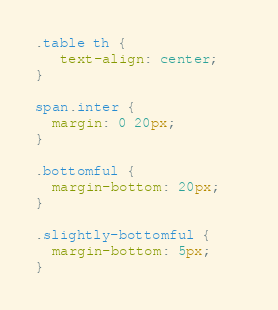Convert code to text. <code><loc_0><loc_0><loc_500><loc_500><_CSS_>.table th {
   text-align: center;   
}

span.inter {
  margin: 0 20px;
}

.bottomful {
  margin-bottom: 20px;
}

.slightly-bottomful {
  margin-bottom: 5px;
}</code> 